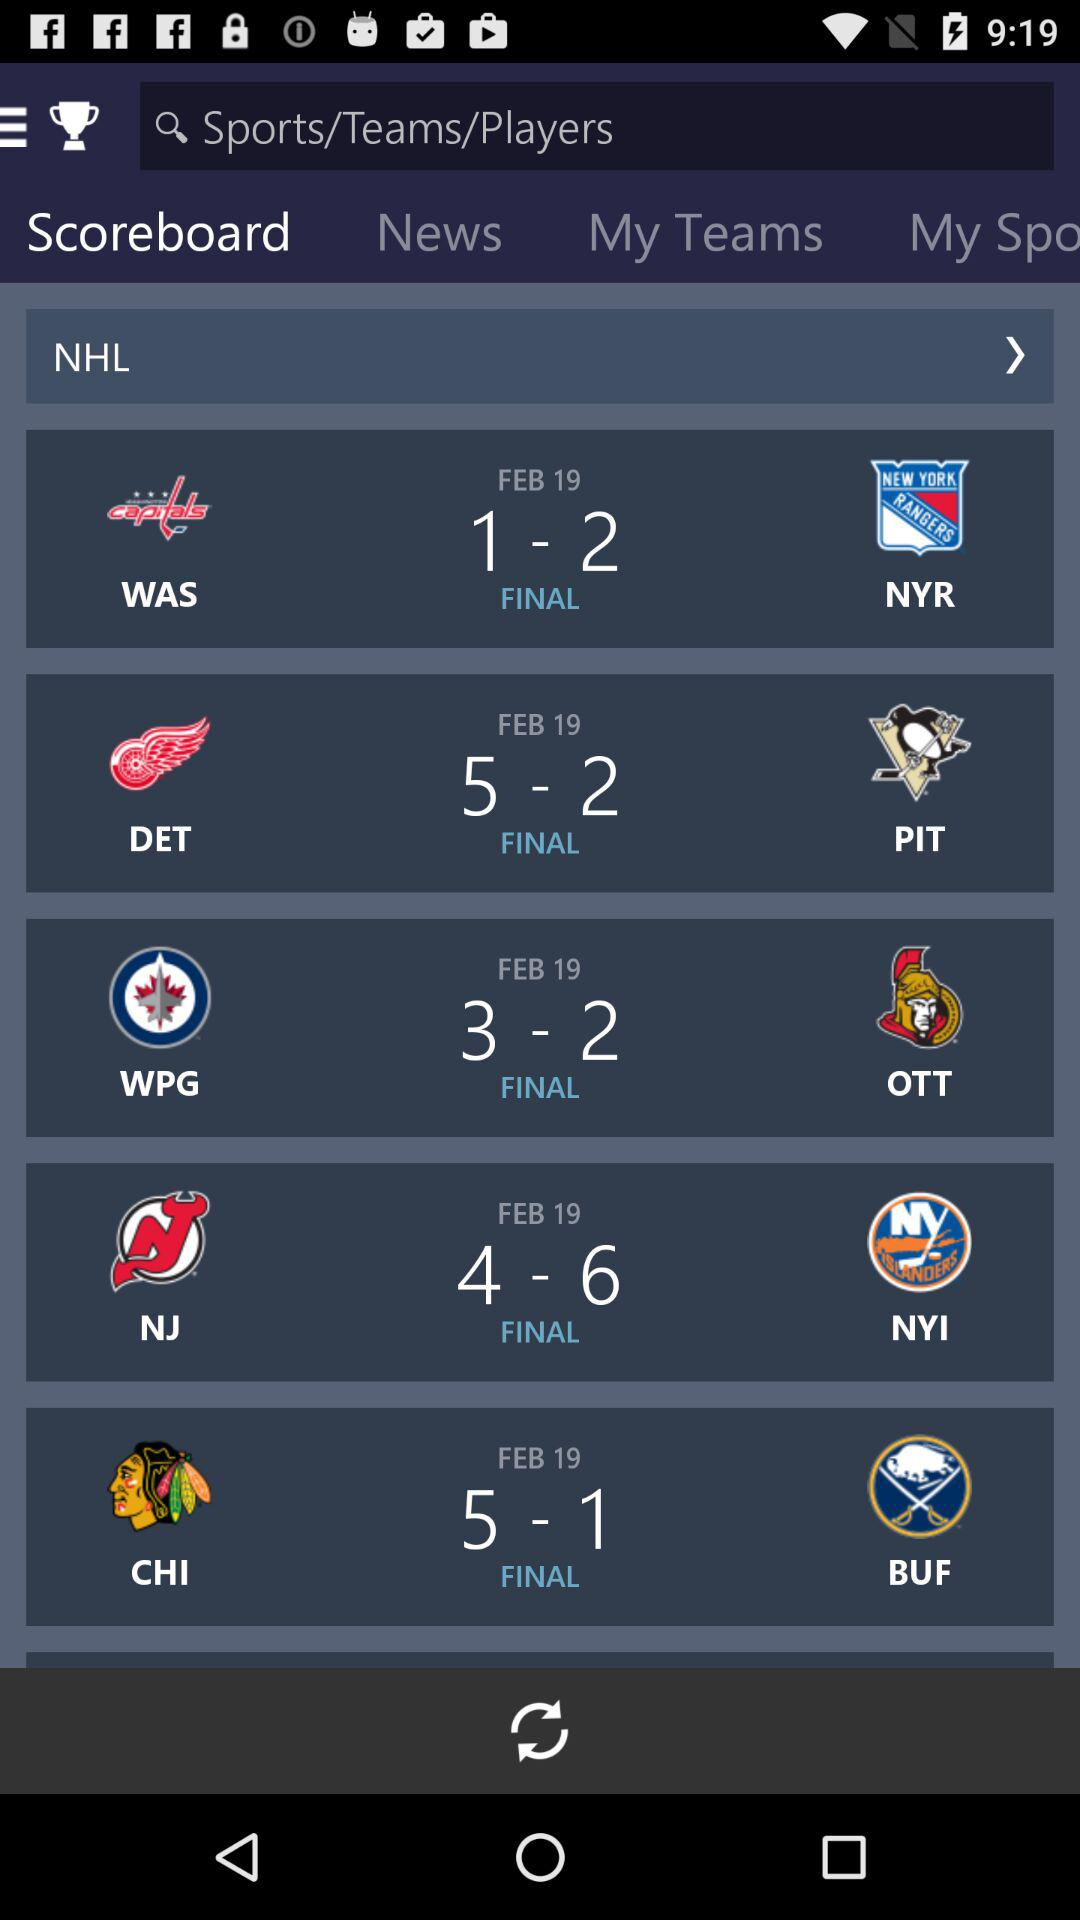How many more points did the Rangers score than the Capitals?
Answer the question using a single word or phrase. 1 